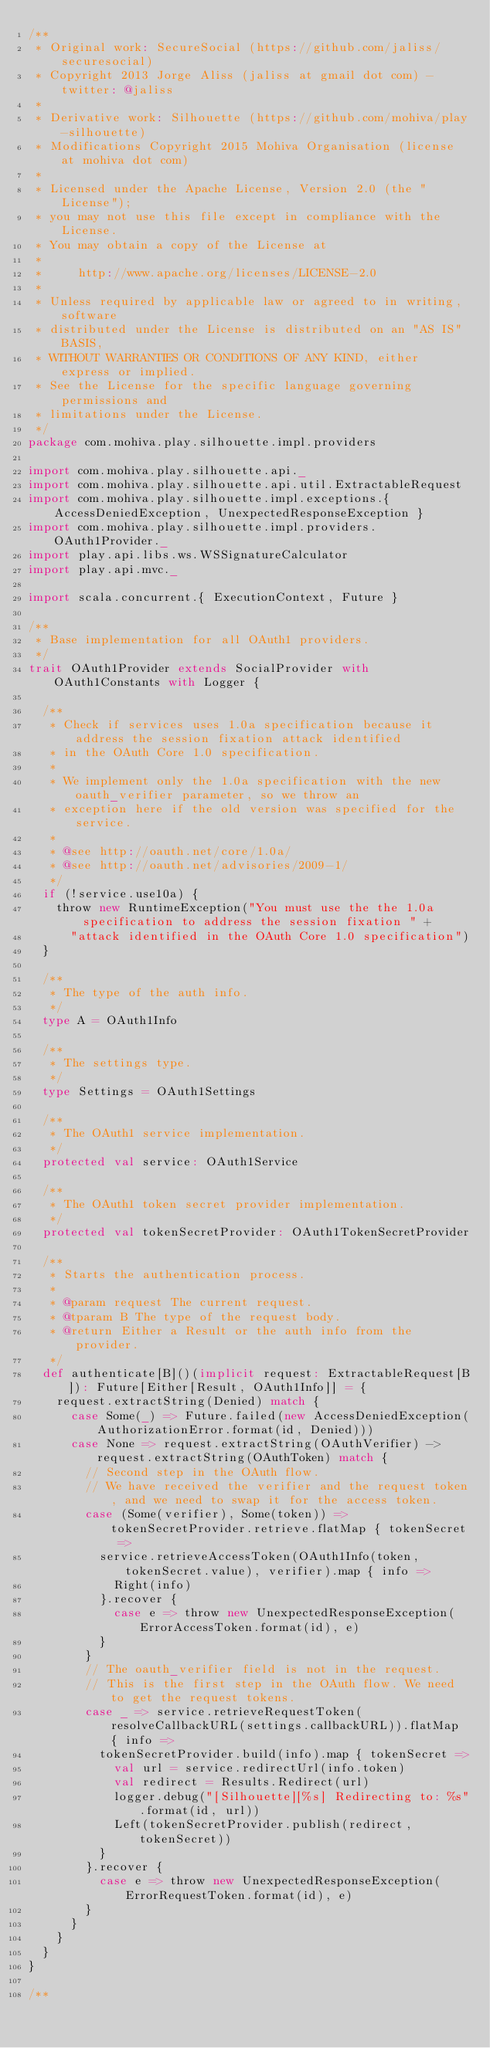Convert code to text. <code><loc_0><loc_0><loc_500><loc_500><_Scala_>/**
 * Original work: SecureSocial (https://github.com/jaliss/securesocial)
 * Copyright 2013 Jorge Aliss (jaliss at gmail dot com) - twitter: @jaliss
 *
 * Derivative work: Silhouette (https://github.com/mohiva/play-silhouette)
 * Modifications Copyright 2015 Mohiva Organisation (license at mohiva dot com)
 *
 * Licensed under the Apache License, Version 2.0 (the "License");
 * you may not use this file except in compliance with the License.
 * You may obtain a copy of the License at
 *
 *     http://www.apache.org/licenses/LICENSE-2.0
 *
 * Unless required by applicable law or agreed to in writing, software
 * distributed under the License is distributed on an "AS IS" BASIS,
 * WITHOUT WARRANTIES OR CONDITIONS OF ANY KIND, either express or implied.
 * See the License for the specific language governing permissions and
 * limitations under the License.
 */
package com.mohiva.play.silhouette.impl.providers

import com.mohiva.play.silhouette.api._
import com.mohiva.play.silhouette.api.util.ExtractableRequest
import com.mohiva.play.silhouette.impl.exceptions.{ AccessDeniedException, UnexpectedResponseException }
import com.mohiva.play.silhouette.impl.providers.OAuth1Provider._
import play.api.libs.ws.WSSignatureCalculator
import play.api.mvc._

import scala.concurrent.{ ExecutionContext, Future }

/**
 * Base implementation for all OAuth1 providers.
 */
trait OAuth1Provider extends SocialProvider with OAuth1Constants with Logger {

  /**
   * Check if services uses 1.0a specification because it address the session fixation attack identified
   * in the OAuth Core 1.0 specification.
   *
   * We implement only the 1.0a specification with the new oauth_verifier parameter, so we throw an
   * exception here if the old version was specified for the service.
   *
   * @see http://oauth.net/core/1.0a/
   * @see http://oauth.net/advisories/2009-1/
   */
  if (!service.use10a) {
    throw new RuntimeException("You must use the the 1.0a specification to address the session fixation " +
      "attack identified in the OAuth Core 1.0 specification")
  }

  /**
   * The type of the auth info.
   */
  type A = OAuth1Info

  /**
   * The settings type.
   */
  type Settings = OAuth1Settings

  /**
   * The OAuth1 service implementation.
   */
  protected val service: OAuth1Service

  /**
   * The OAuth1 token secret provider implementation.
   */
  protected val tokenSecretProvider: OAuth1TokenSecretProvider

  /**
   * Starts the authentication process.
   *
   * @param request The current request.
   * @tparam B The type of the request body.
   * @return Either a Result or the auth info from the provider.
   */
  def authenticate[B]()(implicit request: ExtractableRequest[B]): Future[Either[Result, OAuth1Info]] = {
    request.extractString(Denied) match {
      case Some(_) => Future.failed(new AccessDeniedException(AuthorizationError.format(id, Denied)))
      case None => request.extractString(OAuthVerifier) -> request.extractString(OAuthToken) match {
        // Second step in the OAuth flow.
        // We have received the verifier and the request token, and we need to swap it for the access token.
        case (Some(verifier), Some(token)) => tokenSecretProvider.retrieve.flatMap { tokenSecret =>
          service.retrieveAccessToken(OAuth1Info(token, tokenSecret.value), verifier).map { info =>
            Right(info)
          }.recover {
            case e => throw new UnexpectedResponseException(ErrorAccessToken.format(id), e)
          }
        }
        // The oauth_verifier field is not in the request.
        // This is the first step in the OAuth flow. We need to get the request tokens.
        case _ => service.retrieveRequestToken(resolveCallbackURL(settings.callbackURL)).flatMap { info =>
          tokenSecretProvider.build(info).map { tokenSecret =>
            val url = service.redirectUrl(info.token)
            val redirect = Results.Redirect(url)
            logger.debug("[Silhouette][%s] Redirecting to: %s".format(id, url))
            Left(tokenSecretProvider.publish(redirect, tokenSecret))
          }
        }.recover {
          case e => throw new UnexpectedResponseException(ErrorRequestToken.format(id), e)
        }
      }
    }
  }
}

/**</code> 